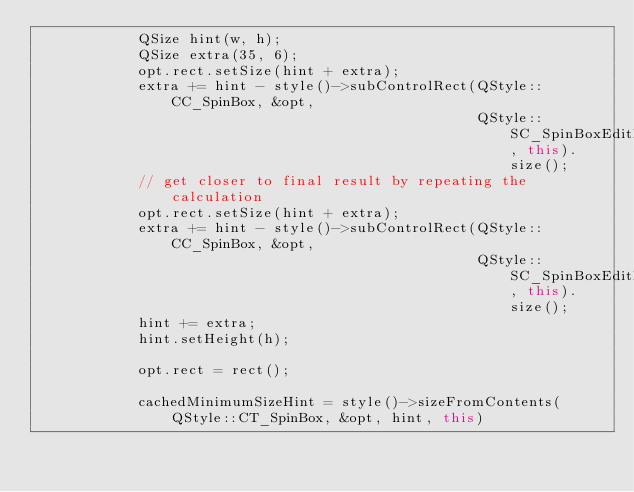<code> <loc_0><loc_0><loc_500><loc_500><_C++_>            QSize hint(w, h);
            QSize extra(35, 6);
            opt.rect.setSize(hint + extra);
            extra += hint - style()->subControlRect(QStyle::CC_SpinBox, &opt,
                                                    QStyle::SC_SpinBoxEditField, this).size();
            // get closer to final result by repeating the calculation
            opt.rect.setSize(hint + extra);
            extra += hint - style()->subControlRect(QStyle::CC_SpinBox, &opt,
                                                    QStyle::SC_SpinBoxEditField, this).size();
            hint += extra;
            hint.setHeight(h);

            opt.rect = rect();

            cachedMinimumSizeHint = style()->sizeFromContents(QStyle::CT_SpinBox, &opt, hint, this)</code> 